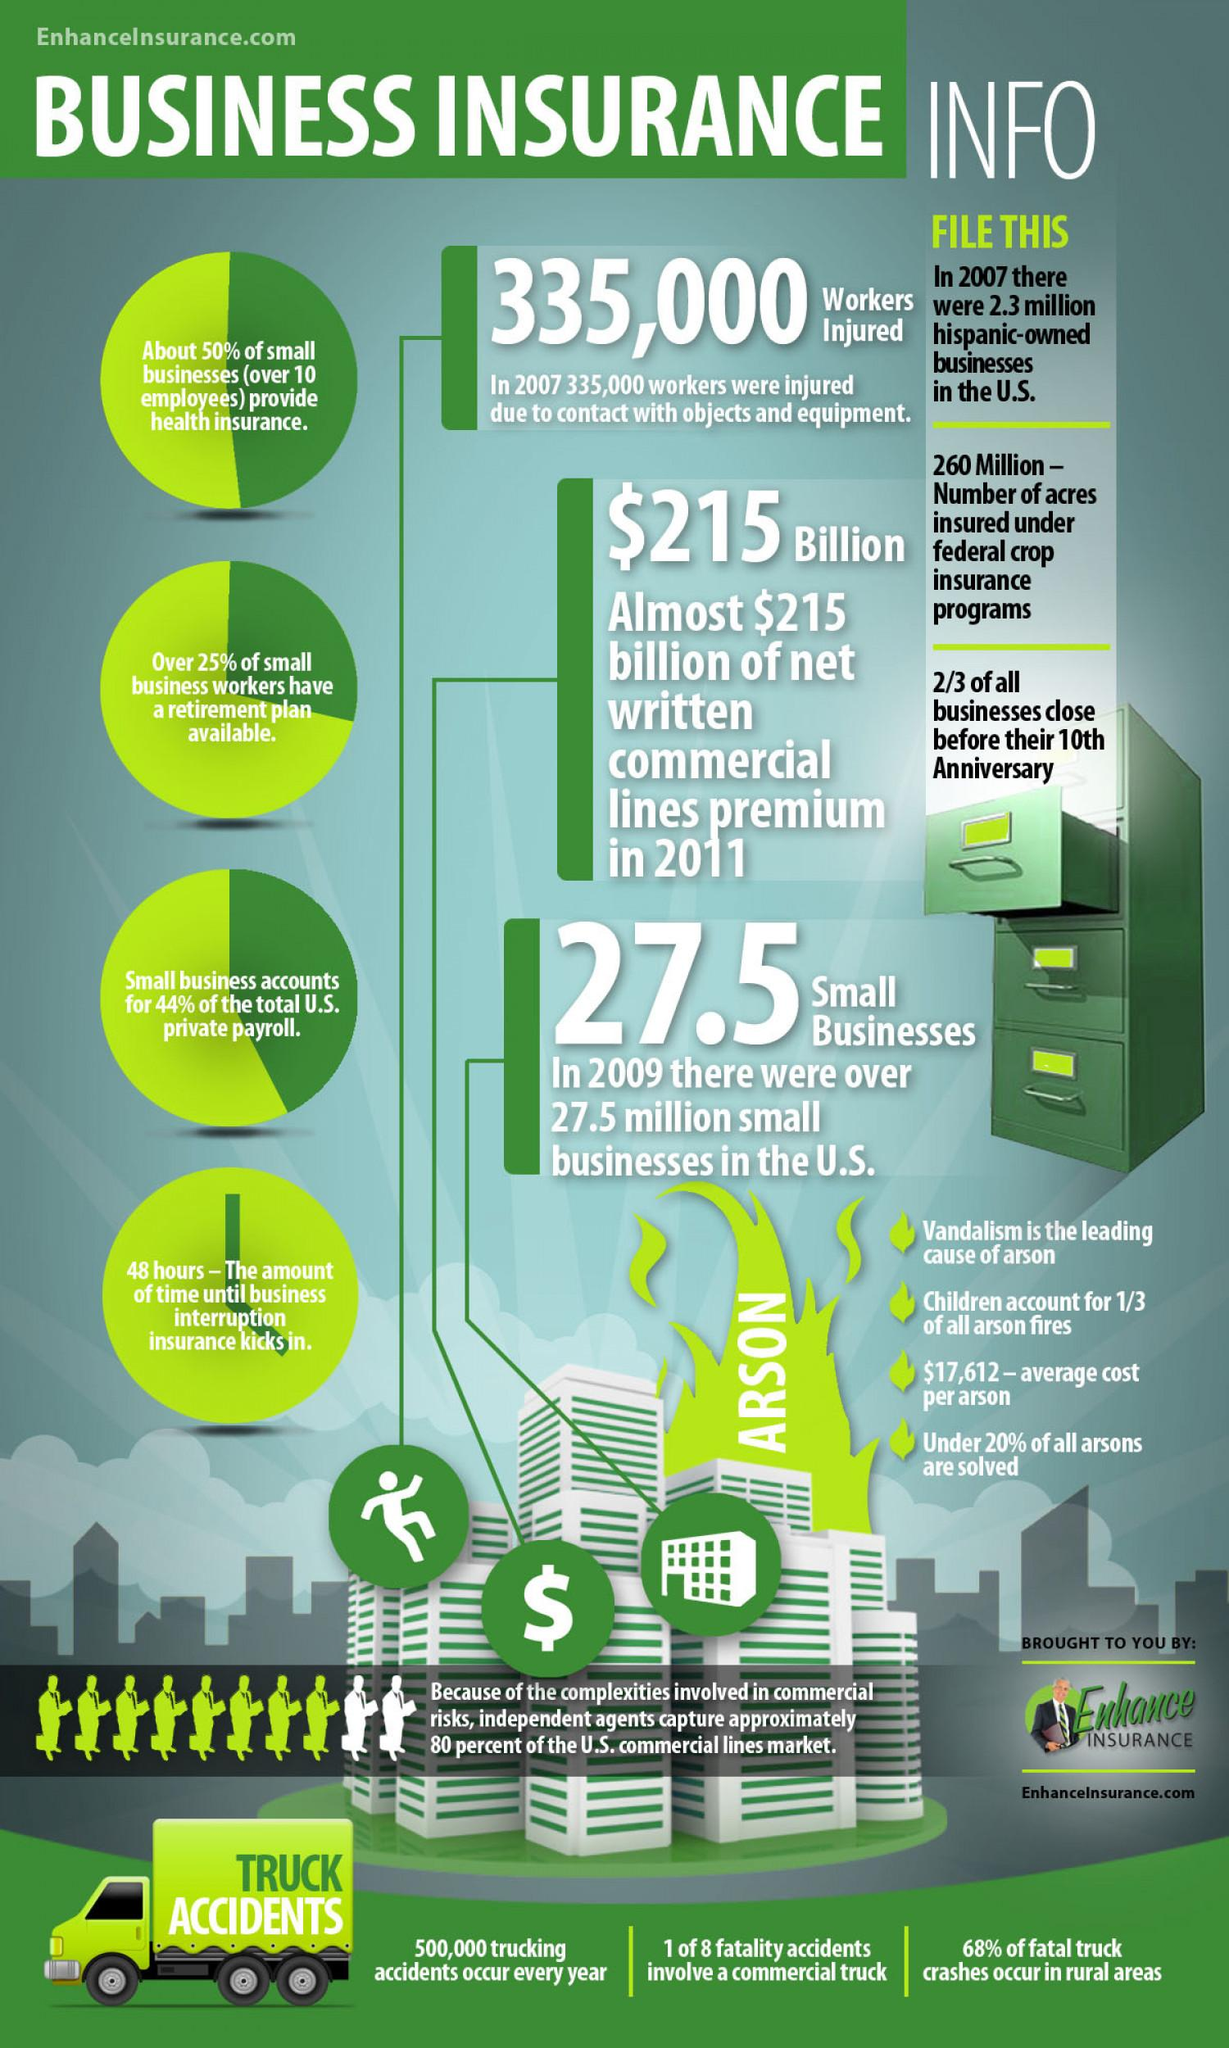Indicate a few pertinent items in this graphic. According to a report, children are responsible for causing one-third of all arson fires. Insurance coverage will typically begin 48 hours after the policy is purchased and all necessary information has been provided to the insurance company. There are approximately 2.3 million Hispanic-owned businesses in the United States. More than 25% of small business workers have access to a retirement plan, indicating a strong commitment to the financial well-being of their employees. Approximately 500,000 accidents are caused by trucks each year. 